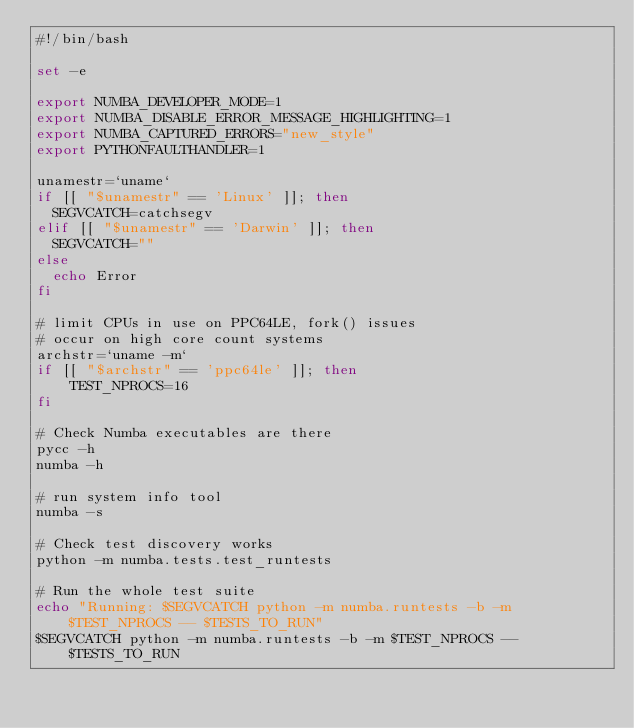<code> <loc_0><loc_0><loc_500><loc_500><_Bash_>#!/bin/bash

set -e

export NUMBA_DEVELOPER_MODE=1
export NUMBA_DISABLE_ERROR_MESSAGE_HIGHLIGHTING=1
export NUMBA_CAPTURED_ERRORS="new_style"
export PYTHONFAULTHANDLER=1

unamestr=`uname`
if [[ "$unamestr" == 'Linux' ]]; then
  SEGVCATCH=catchsegv
elif [[ "$unamestr" == 'Darwin' ]]; then
  SEGVCATCH=""
else
  echo Error
fi

# limit CPUs in use on PPC64LE, fork() issues
# occur on high core count systems
archstr=`uname -m`
if [[ "$archstr" == 'ppc64le' ]]; then
    TEST_NPROCS=16
fi

# Check Numba executables are there
pycc -h
numba -h

# run system info tool
numba -s

# Check test discovery works
python -m numba.tests.test_runtests

# Run the whole test suite
echo "Running: $SEGVCATCH python -m numba.runtests -b -m $TEST_NPROCS -- $TESTS_TO_RUN"
$SEGVCATCH python -m numba.runtests -b -m $TEST_NPROCS -- $TESTS_TO_RUN
</code> 